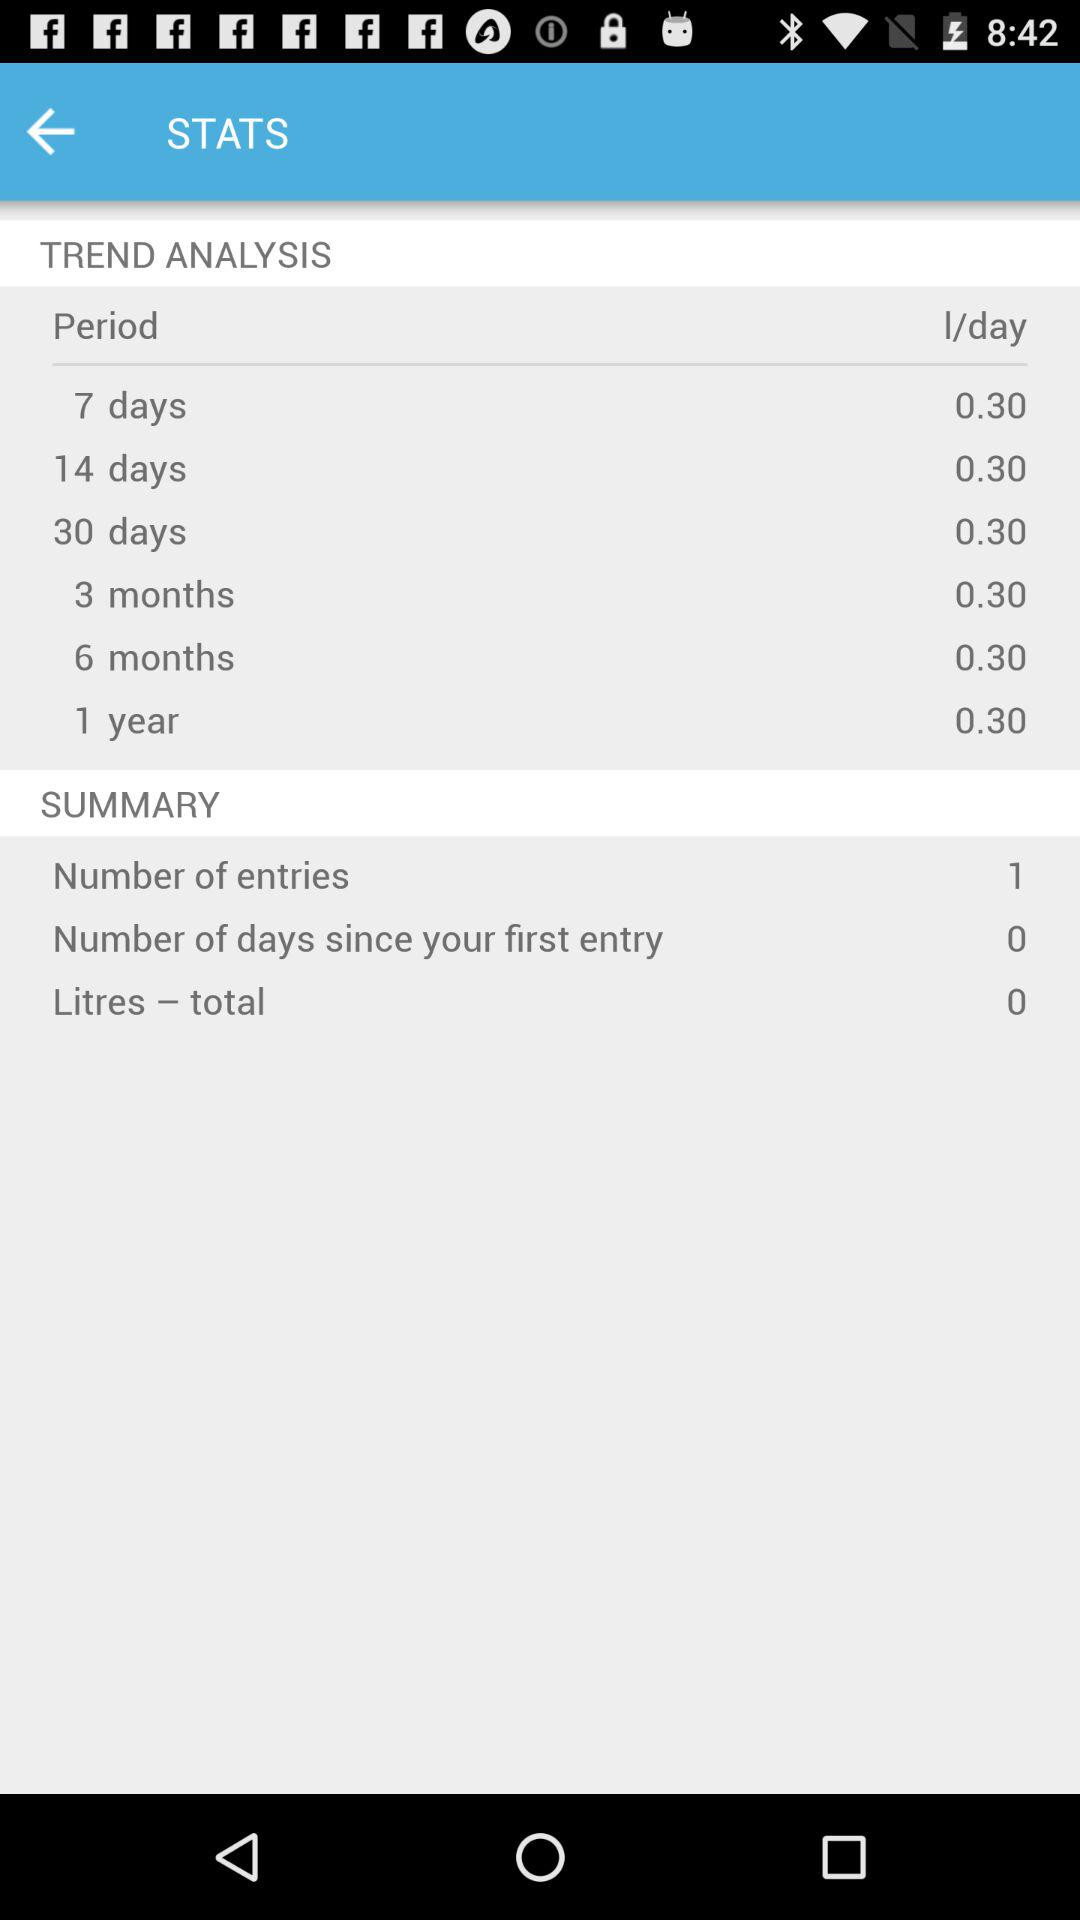How many days since the first entry?
Answer the question using a single word or phrase. 0 